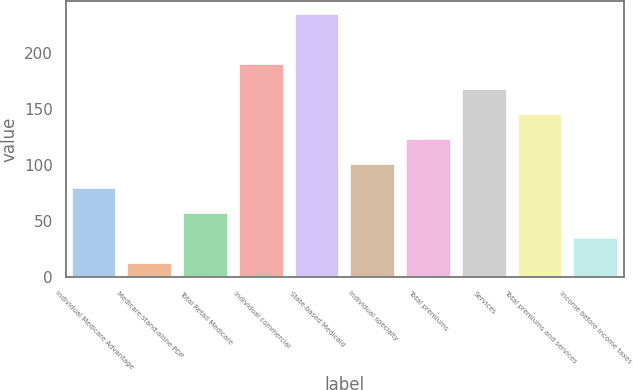Convert chart. <chart><loc_0><loc_0><loc_500><loc_500><bar_chart><fcel>Individual Medicare Advantage<fcel>Medicare stand-alone PDP<fcel>Total Retail Medicare<fcel>Individual commercial<fcel>State-based Medicaid<fcel>Individual specialty<fcel>Total premiums<fcel>Services<fcel>Total premiums and services<fcel>Income before income taxes<nl><fcel>78.84<fcel>12.3<fcel>56.66<fcel>189.74<fcel>234.1<fcel>101.02<fcel>123.2<fcel>167.56<fcel>145.38<fcel>34.48<nl></chart> 